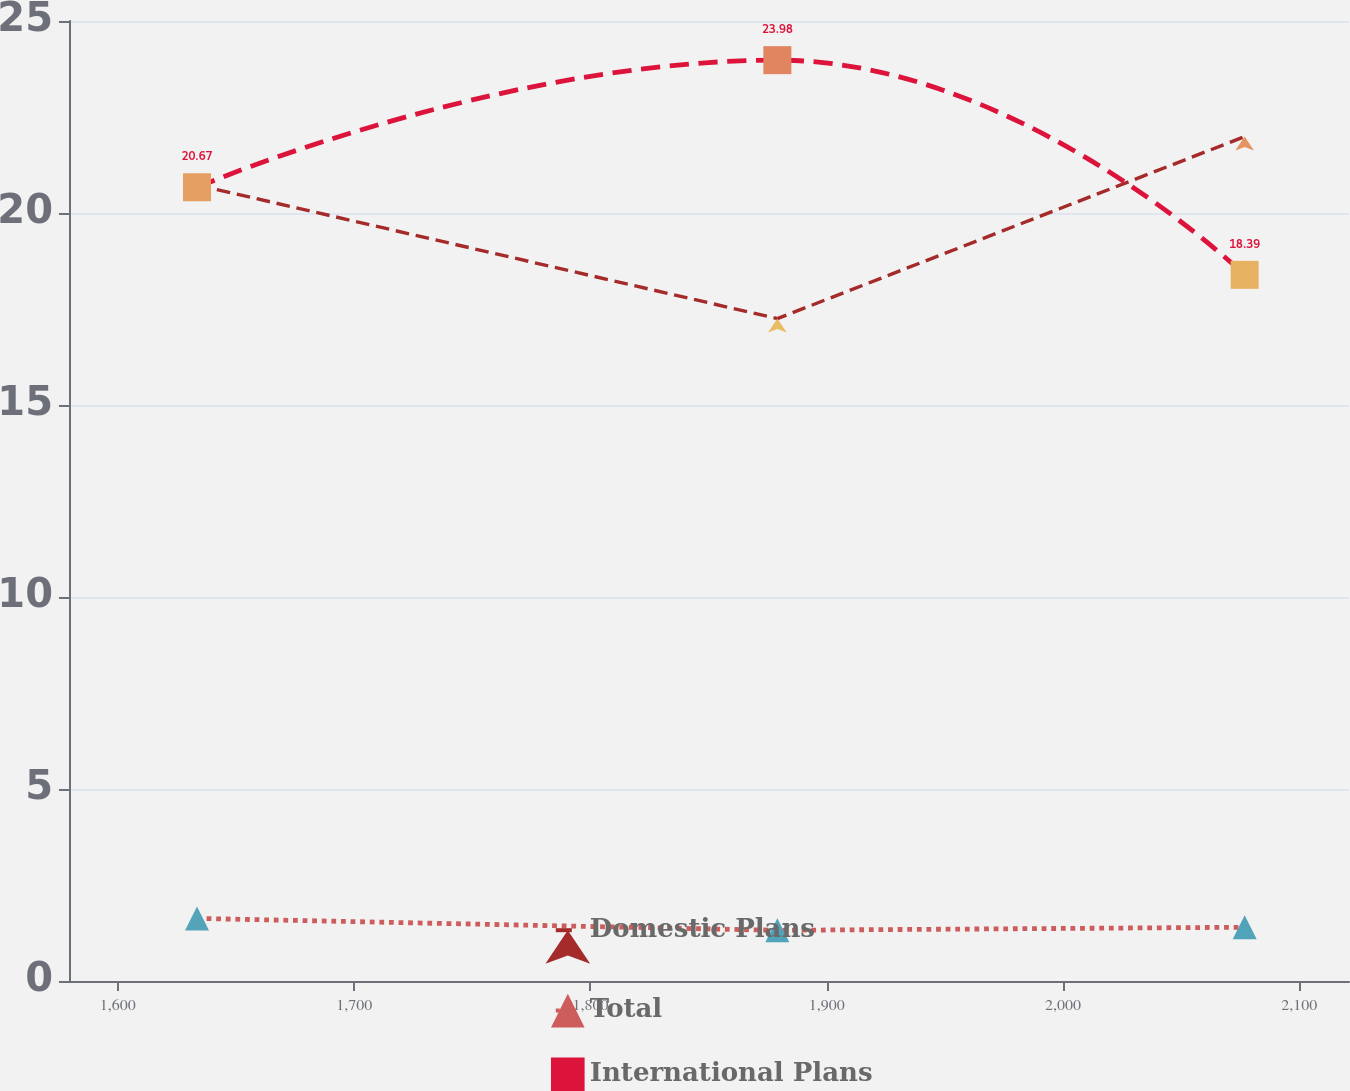<chart> <loc_0><loc_0><loc_500><loc_500><line_chart><ecel><fcel>Domestic Plans<fcel>Total<fcel>International Plans<nl><fcel>1633.5<fcel>20.73<fcel>1.63<fcel>20.67<nl><fcel>1879.12<fcel>17.25<fcel>1.32<fcel>23.98<nl><fcel>2076.89<fcel>21.99<fcel>1.4<fcel>18.39<nl><fcel>2126.05<fcel>19.61<fcel>1.93<fcel>27.66<nl><fcel>2175.22<fcel>25.35<fcel>2.13<fcel>30.48<nl></chart> 